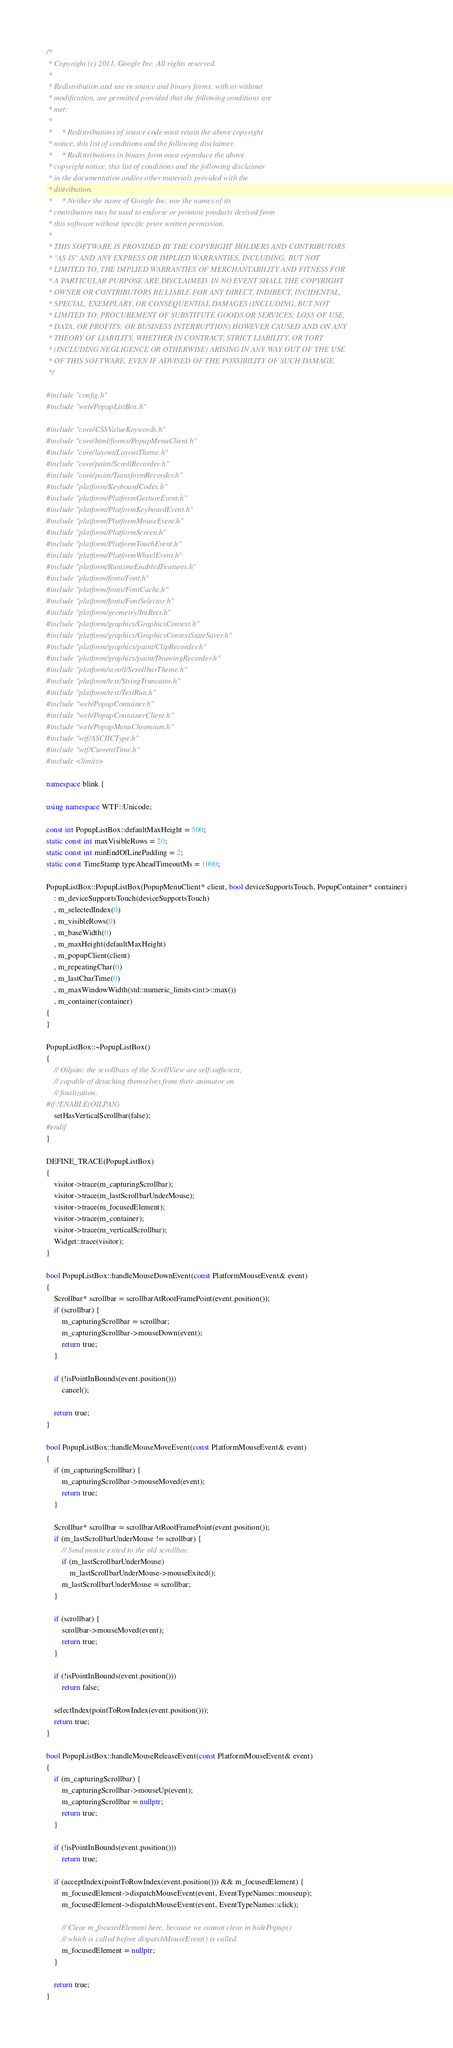Convert code to text. <code><loc_0><loc_0><loc_500><loc_500><_C++_>/*
 * Copyright (c) 2011, Google Inc. All rights reserved.
 *
 * Redistribution and use in source and binary forms, with or without
 * modification, are permitted provided that the following conditions are
 * met:
 *
 *     * Redistributions of source code must retain the above copyright
 * notice, this list of conditions and the following disclaimer.
 *     * Redistributions in binary form must reproduce the above
 * copyright notice, this list of conditions and the following disclaimer
 * in the documentation and/or other materials provided with the
 * distribution.
 *     * Neither the name of Google Inc. nor the names of its
 * contributors may be used to endorse or promote products derived from
 * this software without specific prior written permission.
 *
 * THIS SOFTWARE IS PROVIDED BY THE COPYRIGHT HOLDERS AND CONTRIBUTORS
 * "AS IS" AND ANY EXPRESS OR IMPLIED WARRANTIES, INCLUDING, BUT NOT
 * LIMITED TO, THE IMPLIED WARRANTIES OF MERCHANTABILITY AND FITNESS FOR
 * A PARTICULAR PURPOSE ARE DISCLAIMED. IN NO EVENT SHALL THE COPYRIGHT
 * OWNER OR CONTRIBUTORS BE LIABLE FOR ANY DIRECT, INDIRECT, INCIDENTAL,
 * SPECIAL, EXEMPLARY, OR CONSEQUENTIAL DAMAGES (INCLUDING, BUT NOT
 * LIMITED TO, PROCUREMENT OF SUBSTITUTE GOODS OR SERVICES; LOSS OF USE,
 * DATA, OR PROFITS; OR BUSINESS INTERRUPTION) HOWEVER CAUSED AND ON ANY
 * THEORY OF LIABILITY, WHETHER IN CONTRACT, STRICT LIABILITY, OR TORT
 * (INCLUDING NEGLIGENCE OR OTHERWISE) ARISING IN ANY WAY OUT OF THE USE
 * OF THIS SOFTWARE, EVEN IF ADVISED OF THE POSSIBILITY OF SUCH DAMAGE.
 */

#include "config.h"
#include "web/PopupListBox.h"

#include "core/CSSValueKeywords.h"
#include "core/html/forms/PopupMenuClient.h"
#include "core/layout/LayoutTheme.h"
#include "core/paint/ScrollRecorder.h"
#include "core/paint/TransformRecorder.h"
#include "platform/KeyboardCodes.h"
#include "platform/PlatformGestureEvent.h"
#include "platform/PlatformKeyboardEvent.h"
#include "platform/PlatformMouseEvent.h"
#include "platform/PlatformScreen.h"
#include "platform/PlatformTouchEvent.h"
#include "platform/PlatformWheelEvent.h"
#include "platform/RuntimeEnabledFeatures.h"
#include "platform/fonts/Font.h"
#include "platform/fonts/FontCache.h"
#include "platform/fonts/FontSelector.h"
#include "platform/geometry/IntRect.h"
#include "platform/graphics/GraphicsContext.h"
#include "platform/graphics/GraphicsContextStateSaver.h"
#include "platform/graphics/paint/ClipRecorder.h"
#include "platform/graphics/paint/DrawingRecorder.h"
#include "platform/scroll/ScrollbarTheme.h"
#include "platform/text/StringTruncator.h"
#include "platform/text/TextRun.h"
#include "web/PopupContainer.h"
#include "web/PopupContainerClient.h"
#include "web/PopupMenuChromium.h"
#include "wtf/ASCIICType.h"
#include "wtf/CurrentTime.h"
#include <limits>

namespace blink {

using namespace WTF::Unicode;

const int PopupListBox::defaultMaxHeight = 500;
static const int maxVisibleRows = 20;
static const int minEndOfLinePadding = 2;
static const TimeStamp typeAheadTimeoutMs = 1000;

PopupListBox::PopupListBox(PopupMenuClient* client, bool deviceSupportsTouch, PopupContainer* container)
    : m_deviceSupportsTouch(deviceSupportsTouch)
    , m_selectedIndex(0)
    , m_visibleRows(0)
    , m_baseWidth(0)
    , m_maxHeight(defaultMaxHeight)
    , m_popupClient(client)
    , m_repeatingChar(0)
    , m_lastCharTime(0)
    , m_maxWindowWidth(std::numeric_limits<int>::max())
    , m_container(container)
{
}

PopupListBox::~PopupListBox()
{
    // Oilpan: the scrollbars of the ScrollView are self-sufficient,
    // capable of detaching themselves from their animator on
    // finalization.
#if !ENABLE(OILPAN)
    setHasVerticalScrollbar(false);
#endif
}

DEFINE_TRACE(PopupListBox)
{
    visitor->trace(m_capturingScrollbar);
    visitor->trace(m_lastScrollbarUnderMouse);
    visitor->trace(m_focusedElement);
    visitor->trace(m_container);
    visitor->trace(m_verticalScrollbar);
    Widget::trace(visitor);
}

bool PopupListBox::handleMouseDownEvent(const PlatformMouseEvent& event)
{
    Scrollbar* scrollbar = scrollbarAtRootFramePoint(event.position());
    if (scrollbar) {
        m_capturingScrollbar = scrollbar;
        m_capturingScrollbar->mouseDown(event);
        return true;
    }

    if (!isPointInBounds(event.position()))
        cancel();

    return true;
}

bool PopupListBox::handleMouseMoveEvent(const PlatformMouseEvent& event)
{
    if (m_capturingScrollbar) {
        m_capturingScrollbar->mouseMoved(event);
        return true;
    }

    Scrollbar* scrollbar = scrollbarAtRootFramePoint(event.position());
    if (m_lastScrollbarUnderMouse != scrollbar) {
        // Send mouse exited to the old scrollbar.
        if (m_lastScrollbarUnderMouse)
            m_lastScrollbarUnderMouse->mouseExited();
        m_lastScrollbarUnderMouse = scrollbar;
    }

    if (scrollbar) {
        scrollbar->mouseMoved(event);
        return true;
    }

    if (!isPointInBounds(event.position()))
        return false;

    selectIndex(pointToRowIndex(event.position()));
    return true;
}

bool PopupListBox::handleMouseReleaseEvent(const PlatformMouseEvent& event)
{
    if (m_capturingScrollbar) {
        m_capturingScrollbar->mouseUp(event);
        m_capturingScrollbar = nullptr;
        return true;
    }

    if (!isPointInBounds(event.position()))
        return true;

    if (acceptIndex(pointToRowIndex(event.position())) && m_focusedElement) {
        m_focusedElement->dispatchMouseEvent(event, EventTypeNames::mouseup);
        m_focusedElement->dispatchMouseEvent(event, EventTypeNames::click);

        // Clear m_focusedElement here, because we cannot clear in hidePopup()
        // which is called before dispatchMouseEvent() is called.
        m_focusedElement = nullptr;
    }

    return true;
}
</code> 